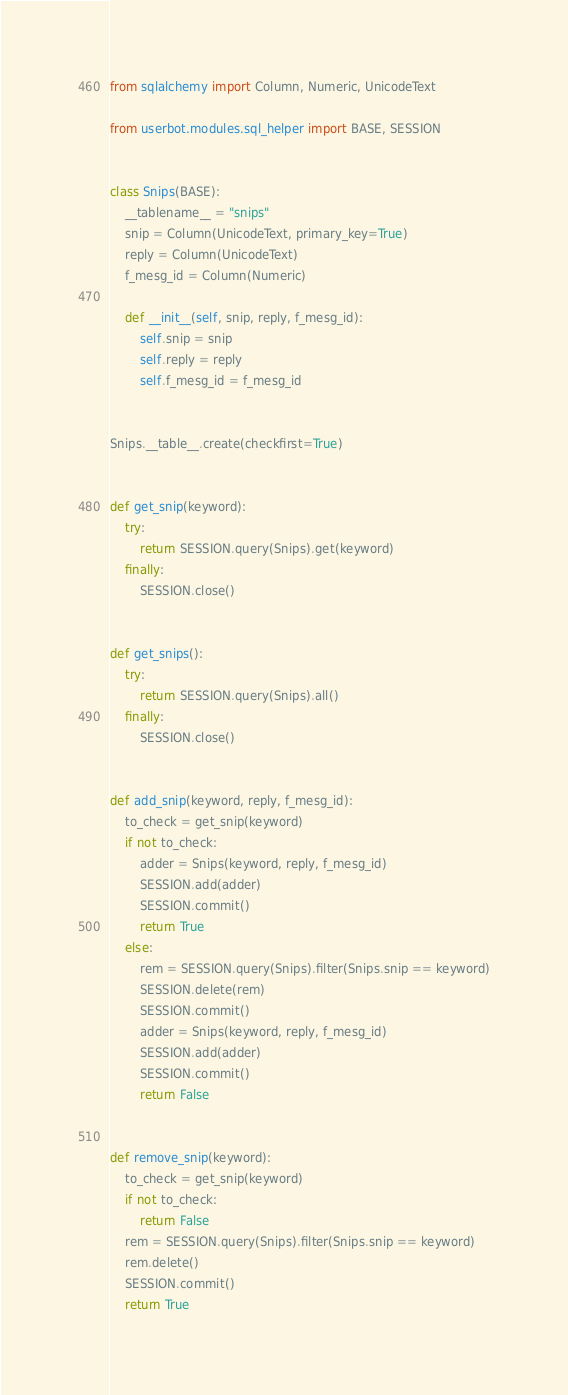Convert code to text. <code><loc_0><loc_0><loc_500><loc_500><_Python_>from sqlalchemy import Column, Numeric, UnicodeText

from userbot.modules.sql_helper import BASE, SESSION


class Snips(BASE):
    __tablename__ = "snips"
    snip = Column(UnicodeText, primary_key=True)
    reply = Column(UnicodeText)
    f_mesg_id = Column(Numeric)

    def __init__(self, snip, reply, f_mesg_id):
        self.snip = snip
        self.reply = reply
        self.f_mesg_id = f_mesg_id


Snips.__table__.create(checkfirst=True)


def get_snip(keyword):
    try:
        return SESSION.query(Snips).get(keyword)
    finally:
        SESSION.close()


def get_snips():
    try:
        return SESSION.query(Snips).all()
    finally:
        SESSION.close()


def add_snip(keyword, reply, f_mesg_id):
    to_check = get_snip(keyword)
    if not to_check:
        adder = Snips(keyword, reply, f_mesg_id)
        SESSION.add(adder)
        SESSION.commit()
        return True
    else:
        rem = SESSION.query(Snips).filter(Snips.snip == keyword)
        SESSION.delete(rem)
        SESSION.commit()
        adder = Snips(keyword, reply, f_mesg_id)
        SESSION.add(adder)
        SESSION.commit()
        return False


def remove_snip(keyword):
    to_check = get_snip(keyword)
    if not to_check:
        return False
    rem = SESSION.query(Snips).filter(Snips.snip == keyword)
    rem.delete()
    SESSION.commit()
    return True
</code> 